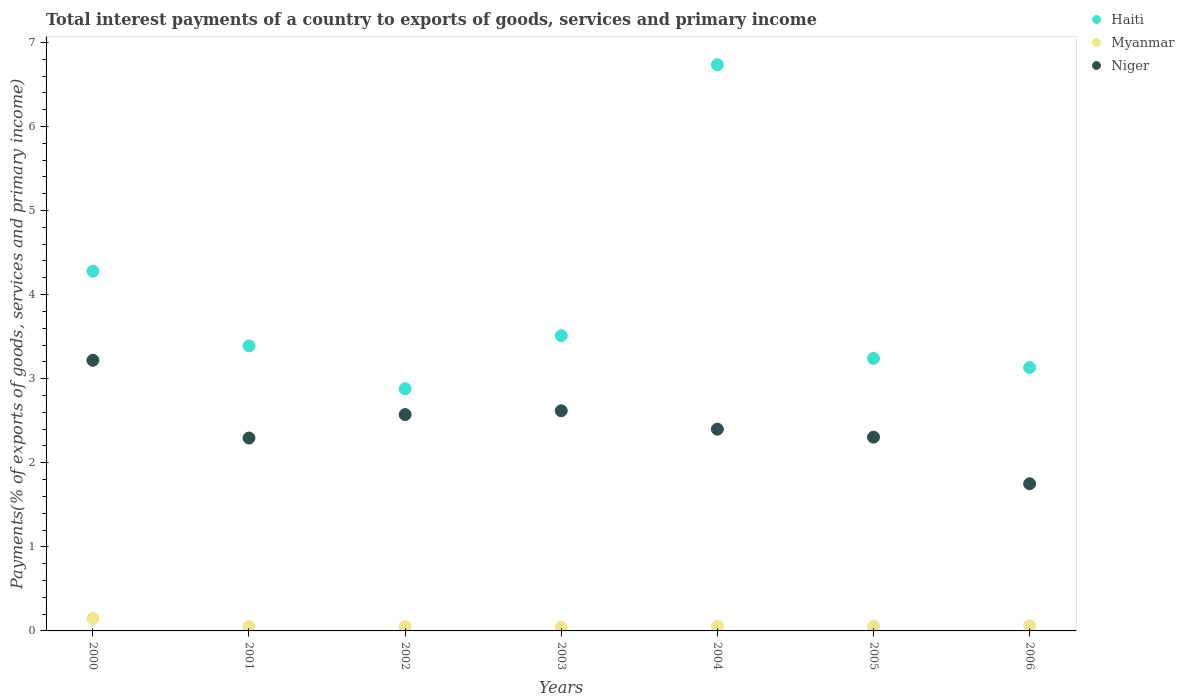How many different coloured dotlines are there?
Provide a short and direct response. 3. Is the number of dotlines equal to the number of legend labels?
Ensure brevity in your answer.  Yes. What is the total interest payments in Niger in 2003?
Your answer should be very brief. 2.62. Across all years, what is the maximum total interest payments in Myanmar?
Give a very brief answer. 0.15. Across all years, what is the minimum total interest payments in Haiti?
Make the answer very short. 2.88. In which year was the total interest payments in Niger maximum?
Offer a terse response. 2000. What is the total total interest payments in Haiti in the graph?
Make the answer very short. 27.17. What is the difference between the total interest payments in Haiti in 2002 and that in 2005?
Offer a terse response. -0.36. What is the difference between the total interest payments in Niger in 2005 and the total interest payments in Haiti in 2001?
Keep it short and to the point. -1.09. What is the average total interest payments in Haiti per year?
Provide a short and direct response. 3.88. In the year 2001, what is the difference between the total interest payments in Niger and total interest payments in Haiti?
Provide a short and direct response. -1.1. In how many years, is the total interest payments in Haiti greater than 6.2 %?
Provide a short and direct response. 1. What is the ratio of the total interest payments in Myanmar in 2004 to that in 2005?
Your response must be concise. 0.98. Is the total interest payments in Myanmar in 2001 less than that in 2002?
Keep it short and to the point. No. What is the difference between the highest and the second highest total interest payments in Myanmar?
Your answer should be compact. 0.09. What is the difference between the highest and the lowest total interest payments in Myanmar?
Provide a short and direct response. 0.11. Is the sum of the total interest payments in Myanmar in 2003 and 2005 greater than the maximum total interest payments in Haiti across all years?
Ensure brevity in your answer.  No. Is the total interest payments in Niger strictly greater than the total interest payments in Myanmar over the years?
Provide a short and direct response. Yes. How many dotlines are there?
Your answer should be very brief. 3. How many years are there in the graph?
Give a very brief answer. 7. What is the difference between two consecutive major ticks on the Y-axis?
Your answer should be compact. 1. Does the graph contain any zero values?
Offer a very short reply. No. Does the graph contain grids?
Your response must be concise. No. How many legend labels are there?
Your answer should be very brief. 3. How are the legend labels stacked?
Your answer should be very brief. Vertical. What is the title of the graph?
Your answer should be very brief. Total interest payments of a country to exports of goods, services and primary income. What is the label or title of the Y-axis?
Your answer should be very brief. Payments(% of exports of goods, services and primary income). What is the Payments(% of exports of goods, services and primary income) in Haiti in 2000?
Offer a terse response. 4.28. What is the Payments(% of exports of goods, services and primary income) of Myanmar in 2000?
Keep it short and to the point. 0.15. What is the Payments(% of exports of goods, services and primary income) of Niger in 2000?
Your answer should be very brief. 3.22. What is the Payments(% of exports of goods, services and primary income) of Haiti in 2001?
Your response must be concise. 3.39. What is the Payments(% of exports of goods, services and primary income) in Myanmar in 2001?
Provide a short and direct response. 0.05. What is the Payments(% of exports of goods, services and primary income) of Niger in 2001?
Keep it short and to the point. 2.29. What is the Payments(% of exports of goods, services and primary income) of Haiti in 2002?
Offer a terse response. 2.88. What is the Payments(% of exports of goods, services and primary income) in Myanmar in 2002?
Your response must be concise. 0.05. What is the Payments(% of exports of goods, services and primary income) of Niger in 2002?
Provide a succinct answer. 2.57. What is the Payments(% of exports of goods, services and primary income) in Haiti in 2003?
Your answer should be compact. 3.51. What is the Payments(% of exports of goods, services and primary income) in Myanmar in 2003?
Give a very brief answer. 0.04. What is the Payments(% of exports of goods, services and primary income) of Niger in 2003?
Provide a short and direct response. 2.62. What is the Payments(% of exports of goods, services and primary income) in Haiti in 2004?
Give a very brief answer. 6.73. What is the Payments(% of exports of goods, services and primary income) in Myanmar in 2004?
Your answer should be very brief. 0.05. What is the Payments(% of exports of goods, services and primary income) of Niger in 2004?
Offer a terse response. 2.4. What is the Payments(% of exports of goods, services and primary income) of Haiti in 2005?
Offer a very short reply. 3.24. What is the Payments(% of exports of goods, services and primary income) of Myanmar in 2005?
Ensure brevity in your answer.  0.05. What is the Payments(% of exports of goods, services and primary income) in Niger in 2005?
Keep it short and to the point. 2.3. What is the Payments(% of exports of goods, services and primary income) in Haiti in 2006?
Your response must be concise. 3.13. What is the Payments(% of exports of goods, services and primary income) in Myanmar in 2006?
Ensure brevity in your answer.  0.06. What is the Payments(% of exports of goods, services and primary income) of Niger in 2006?
Give a very brief answer. 1.75. Across all years, what is the maximum Payments(% of exports of goods, services and primary income) of Haiti?
Provide a succinct answer. 6.73. Across all years, what is the maximum Payments(% of exports of goods, services and primary income) of Myanmar?
Keep it short and to the point. 0.15. Across all years, what is the maximum Payments(% of exports of goods, services and primary income) in Niger?
Offer a terse response. 3.22. Across all years, what is the minimum Payments(% of exports of goods, services and primary income) in Haiti?
Offer a terse response. 2.88. Across all years, what is the minimum Payments(% of exports of goods, services and primary income) in Myanmar?
Ensure brevity in your answer.  0.04. Across all years, what is the minimum Payments(% of exports of goods, services and primary income) in Niger?
Provide a short and direct response. 1.75. What is the total Payments(% of exports of goods, services and primary income) in Haiti in the graph?
Your answer should be compact. 27.17. What is the total Payments(% of exports of goods, services and primary income) in Myanmar in the graph?
Keep it short and to the point. 0.46. What is the total Payments(% of exports of goods, services and primary income) in Niger in the graph?
Your response must be concise. 17.16. What is the difference between the Payments(% of exports of goods, services and primary income) in Haiti in 2000 and that in 2001?
Offer a very short reply. 0.89. What is the difference between the Payments(% of exports of goods, services and primary income) of Myanmar in 2000 and that in 2001?
Keep it short and to the point. 0.1. What is the difference between the Payments(% of exports of goods, services and primary income) in Niger in 2000 and that in 2001?
Keep it short and to the point. 0.92. What is the difference between the Payments(% of exports of goods, services and primary income) of Haiti in 2000 and that in 2002?
Provide a short and direct response. 1.4. What is the difference between the Payments(% of exports of goods, services and primary income) in Myanmar in 2000 and that in 2002?
Offer a very short reply. 0.1. What is the difference between the Payments(% of exports of goods, services and primary income) of Niger in 2000 and that in 2002?
Provide a succinct answer. 0.65. What is the difference between the Payments(% of exports of goods, services and primary income) in Haiti in 2000 and that in 2003?
Make the answer very short. 0.77. What is the difference between the Payments(% of exports of goods, services and primary income) in Myanmar in 2000 and that in 2003?
Keep it short and to the point. 0.11. What is the difference between the Payments(% of exports of goods, services and primary income) in Niger in 2000 and that in 2003?
Give a very brief answer. 0.6. What is the difference between the Payments(% of exports of goods, services and primary income) of Haiti in 2000 and that in 2004?
Provide a short and direct response. -2.46. What is the difference between the Payments(% of exports of goods, services and primary income) of Myanmar in 2000 and that in 2004?
Your response must be concise. 0.1. What is the difference between the Payments(% of exports of goods, services and primary income) of Niger in 2000 and that in 2004?
Ensure brevity in your answer.  0.82. What is the difference between the Payments(% of exports of goods, services and primary income) of Haiti in 2000 and that in 2005?
Offer a very short reply. 1.04. What is the difference between the Payments(% of exports of goods, services and primary income) in Myanmar in 2000 and that in 2005?
Give a very brief answer. 0.09. What is the difference between the Payments(% of exports of goods, services and primary income) of Niger in 2000 and that in 2005?
Keep it short and to the point. 0.91. What is the difference between the Payments(% of exports of goods, services and primary income) of Haiti in 2000 and that in 2006?
Your answer should be very brief. 1.15. What is the difference between the Payments(% of exports of goods, services and primary income) of Myanmar in 2000 and that in 2006?
Offer a terse response. 0.09. What is the difference between the Payments(% of exports of goods, services and primary income) of Niger in 2000 and that in 2006?
Your answer should be compact. 1.47. What is the difference between the Payments(% of exports of goods, services and primary income) in Haiti in 2001 and that in 2002?
Provide a short and direct response. 0.51. What is the difference between the Payments(% of exports of goods, services and primary income) of Myanmar in 2001 and that in 2002?
Offer a terse response. 0. What is the difference between the Payments(% of exports of goods, services and primary income) of Niger in 2001 and that in 2002?
Keep it short and to the point. -0.28. What is the difference between the Payments(% of exports of goods, services and primary income) in Haiti in 2001 and that in 2003?
Give a very brief answer. -0.12. What is the difference between the Payments(% of exports of goods, services and primary income) of Myanmar in 2001 and that in 2003?
Keep it short and to the point. 0.01. What is the difference between the Payments(% of exports of goods, services and primary income) in Niger in 2001 and that in 2003?
Offer a terse response. -0.32. What is the difference between the Payments(% of exports of goods, services and primary income) of Haiti in 2001 and that in 2004?
Your response must be concise. -3.34. What is the difference between the Payments(% of exports of goods, services and primary income) of Myanmar in 2001 and that in 2004?
Give a very brief answer. -0. What is the difference between the Payments(% of exports of goods, services and primary income) in Niger in 2001 and that in 2004?
Your response must be concise. -0.11. What is the difference between the Payments(% of exports of goods, services and primary income) in Haiti in 2001 and that in 2005?
Your answer should be very brief. 0.15. What is the difference between the Payments(% of exports of goods, services and primary income) in Myanmar in 2001 and that in 2005?
Give a very brief answer. -0. What is the difference between the Payments(% of exports of goods, services and primary income) of Niger in 2001 and that in 2005?
Provide a succinct answer. -0.01. What is the difference between the Payments(% of exports of goods, services and primary income) of Haiti in 2001 and that in 2006?
Ensure brevity in your answer.  0.26. What is the difference between the Payments(% of exports of goods, services and primary income) in Myanmar in 2001 and that in 2006?
Offer a terse response. -0.01. What is the difference between the Payments(% of exports of goods, services and primary income) in Niger in 2001 and that in 2006?
Your answer should be very brief. 0.54. What is the difference between the Payments(% of exports of goods, services and primary income) in Haiti in 2002 and that in 2003?
Give a very brief answer. -0.63. What is the difference between the Payments(% of exports of goods, services and primary income) in Myanmar in 2002 and that in 2003?
Provide a short and direct response. 0.01. What is the difference between the Payments(% of exports of goods, services and primary income) of Niger in 2002 and that in 2003?
Ensure brevity in your answer.  -0.05. What is the difference between the Payments(% of exports of goods, services and primary income) of Haiti in 2002 and that in 2004?
Ensure brevity in your answer.  -3.85. What is the difference between the Payments(% of exports of goods, services and primary income) in Myanmar in 2002 and that in 2004?
Give a very brief answer. -0. What is the difference between the Payments(% of exports of goods, services and primary income) in Niger in 2002 and that in 2004?
Ensure brevity in your answer.  0.17. What is the difference between the Payments(% of exports of goods, services and primary income) of Haiti in 2002 and that in 2005?
Offer a terse response. -0.36. What is the difference between the Payments(% of exports of goods, services and primary income) of Myanmar in 2002 and that in 2005?
Offer a terse response. -0. What is the difference between the Payments(% of exports of goods, services and primary income) in Niger in 2002 and that in 2005?
Your response must be concise. 0.27. What is the difference between the Payments(% of exports of goods, services and primary income) of Haiti in 2002 and that in 2006?
Your answer should be very brief. -0.25. What is the difference between the Payments(% of exports of goods, services and primary income) of Myanmar in 2002 and that in 2006?
Give a very brief answer. -0.01. What is the difference between the Payments(% of exports of goods, services and primary income) of Niger in 2002 and that in 2006?
Keep it short and to the point. 0.82. What is the difference between the Payments(% of exports of goods, services and primary income) of Haiti in 2003 and that in 2004?
Make the answer very short. -3.22. What is the difference between the Payments(% of exports of goods, services and primary income) in Myanmar in 2003 and that in 2004?
Keep it short and to the point. -0.01. What is the difference between the Payments(% of exports of goods, services and primary income) of Niger in 2003 and that in 2004?
Ensure brevity in your answer.  0.22. What is the difference between the Payments(% of exports of goods, services and primary income) of Haiti in 2003 and that in 2005?
Give a very brief answer. 0.27. What is the difference between the Payments(% of exports of goods, services and primary income) in Myanmar in 2003 and that in 2005?
Your response must be concise. -0.01. What is the difference between the Payments(% of exports of goods, services and primary income) of Niger in 2003 and that in 2005?
Ensure brevity in your answer.  0.31. What is the difference between the Payments(% of exports of goods, services and primary income) in Haiti in 2003 and that in 2006?
Keep it short and to the point. 0.38. What is the difference between the Payments(% of exports of goods, services and primary income) in Myanmar in 2003 and that in 2006?
Offer a terse response. -0.02. What is the difference between the Payments(% of exports of goods, services and primary income) in Niger in 2003 and that in 2006?
Your answer should be compact. 0.87. What is the difference between the Payments(% of exports of goods, services and primary income) in Haiti in 2004 and that in 2005?
Offer a terse response. 3.49. What is the difference between the Payments(% of exports of goods, services and primary income) in Myanmar in 2004 and that in 2005?
Provide a short and direct response. -0. What is the difference between the Payments(% of exports of goods, services and primary income) in Niger in 2004 and that in 2005?
Provide a succinct answer. 0.09. What is the difference between the Payments(% of exports of goods, services and primary income) of Haiti in 2004 and that in 2006?
Give a very brief answer. 3.6. What is the difference between the Payments(% of exports of goods, services and primary income) in Myanmar in 2004 and that in 2006?
Make the answer very short. -0.01. What is the difference between the Payments(% of exports of goods, services and primary income) of Niger in 2004 and that in 2006?
Provide a short and direct response. 0.65. What is the difference between the Payments(% of exports of goods, services and primary income) in Haiti in 2005 and that in 2006?
Give a very brief answer. 0.11. What is the difference between the Payments(% of exports of goods, services and primary income) of Myanmar in 2005 and that in 2006?
Give a very brief answer. -0.01. What is the difference between the Payments(% of exports of goods, services and primary income) of Niger in 2005 and that in 2006?
Ensure brevity in your answer.  0.55. What is the difference between the Payments(% of exports of goods, services and primary income) in Haiti in 2000 and the Payments(% of exports of goods, services and primary income) in Myanmar in 2001?
Ensure brevity in your answer.  4.23. What is the difference between the Payments(% of exports of goods, services and primary income) of Haiti in 2000 and the Payments(% of exports of goods, services and primary income) of Niger in 2001?
Your response must be concise. 1.98. What is the difference between the Payments(% of exports of goods, services and primary income) of Myanmar in 2000 and the Payments(% of exports of goods, services and primary income) of Niger in 2001?
Provide a short and direct response. -2.15. What is the difference between the Payments(% of exports of goods, services and primary income) in Haiti in 2000 and the Payments(% of exports of goods, services and primary income) in Myanmar in 2002?
Offer a very short reply. 4.23. What is the difference between the Payments(% of exports of goods, services and primary income) in Haiti in 2000 and the Payments(% of exports of goods, services and primary income) in Niger in 2002?
Provide a short and direct response. 1.71. What is the difference between the Payments(% of exports of goods, services and primary income) of Myanmar in 2000 and the Payments(% of exports of goods, services and primary income) of Niger in 2002?
Keep it short and to the point. -2.42. What is the difference between the Payments(% of exports of goods, services and primary income) of Haiti in 2000 and the Payments(% of exports of goods, services and primary income) of Myanmar in 2003?
Keep it short and to the point. 4.24. What is the difference between the Payments(% of exports of goods, services and primary income) of Haiti in 2000 and the Payments(% of exports of goods, services and primary income) of Niger in 2003?
Provide a succinct answer. 1.66. What is the difference between the Payments(% of exports of goods, services and primary income) of Myanmar in 2000 and the Payments(% of exports of goods, services and primary income) of Niger in 2003?
Offer a terse response. -2.47. What is the difference between the Payments(% of exports of goods, services and primary income) in Haiti in 2000 and the Payments(% of exports of goods, services and primary income) in Myanmar in 2004?
Ensure brevity in your answer.  4.23. What is the difference between the Payments(% of exports of goods, services and primary income) of Haiti in 2000 and the Payments(% of exports of goods, services and primary income) of Niger in 2004?
Offer a very short reply. 1.88. What is the difference between the Payments(% of exports of goods, services and primary income) of Myanmar in 2000 and the Payments(% of exports of goods, services and primary income) of Niger in 2004?
Ensure brevity in your answer.  -2.25. What is the difference between the Payments(% of exports of goods, services and primary income) in Haiti in 2000 and the Payments(% of exports of goods, services and primary income) in Myanmar in 2005?
Provide a succinct answer. 4.22. What is the difference between the Payments(% of exports of goods, services and primary income) in Haiti in 2000 and the Payments(% of exports of goods, services and primary income) in Niger in 2005?
Offer a terse response. 1.97. What is the difference between the Payments(% of exports of goods, services and primary income) of Myanmar in 2000 and the Payments(% of exports of goods, services and primary income) of Niger in 2005?
Offer a very short reply. -2.16. What is the difference between the Payments(% of exports of goods, services and primary income) in Haiti in 2000 and the Payments(% of exports of goods, services and primary income) in Myanmar in 2006?
Provide a succinct answer. 4.22. What is the difference between the Payments(% of exports of goods, services and primary income) in Haiti in 2000 and the Payments(% of exports of goods, services and primary income) in Niger in 2006?
Your response must be concise. 2.53. What is the difference between the Payments(% of exports of goods, services and primary income) of Myanmar in 2000 and the Payments(% of exports of goods, services and primary income) of Niger in 2006?
Ensure brevity in your answer.  -1.6. What is the difference between the Payments(% of exports of goods, services and primary income) in Haiti in 2001 and the Payments(% of exports of goods, services and primary income) in Myanmar in 2002?
Your answer should be very brief. 3.34. What is the difference between the Payments(% of exports of goods, services and primary income) in Haiti in 2001 and the Payments(% of exports of goods, services and primary income) in Niger in 2002?
Offer a very short reply. 0.82. What is the difference between the Payments(% of exports of goods, services and primary income) of Myanmar in 2001 and the Payments(% of exports of goods, services and primary income) of Niger in 2002?
Keep it short and to the point. -2.52. What is the difference between the Payments(% of exports of goods, services and primary income) of Haiti in 2001 and the Payments(% of exports of goods, services and primary income) of Myanmar in 2003?
Your answer should be very brief. 3.35. What is the difference between the Payments(% of exports of goods, services and primary income) of Haiti in 2001 and the Payments(% of exports of goods, services and primary income) of Niger in 2003?
Provide a succinct answer. 0.77. What is the difference between the Payments(% of exports of goods, services and primary income) of Myanmar in 2001 and the Payments(% of exports of goods, services and primary income) of Niger in 2003?
Offer a terse response. -2.57. What is the difference between the Payments(% of exports of goods, services and primary income) in Haiti in 2001 and the Payments(% of exports of goods, services and primary income) in Myanmar in 2004?
Your answer should be compact. 3.34. What is the difference between the Payments(% of exports of goods, services and primary income) of Myanmar in 2001 and the Payments(% of exports of goods, services and primary income) of Niger in 2004?
Offer a terse response. -2.35. What is the difference between the Payments(% of exports of goods, services and primary income) of Haiti in 2001 and the Payments(% of exports of goods, services and primary income) of Myanmar in 2005?
Your answer should be compact. 3.34. What is the difference between the Payments(% of exports of goods, services and primary income) of Haiti in 2001 and the Payments(% of exports of goods, services and primary income) of Niger in 2005?
Your response must be concise. 1.09. What is the difference between the Payments(% of exports of goods, services and primary income) in Myanmar in 2001 and the Payments(% of exports of goods, services and primary income) in Niger in 2005?
Give a very brief answer. -2.25. What is the difference between the Payments(% of exports of goods, services and primary income) in Haiti in 2001 and the Payments(% of exports of goods, services and primary income) in Myanmar in 2006?
Keep it short and to the point. 3.33. What is the difference between the Payments(% of exports of goods, services and primary income) in Haiti in 2001 and the Payments(% of exports of goods, services and primary income) in Niger in 2006?
Your answer should be compact. 1.64. What is the difference between the Payments(% of exports of goods, services and primary income) in Myanmar in 2001 and the Payments(% of exports of goods, services and primary income) in Niger in 2006?
Provide a short and direct response. -1.7. What is the difference between the Payments(% of exports of goods, services and primary income) in Haiti in 2002 and the Payments(% of exports of goods, services and primary income) in Myanmar in 2003?
Offer a very short reply. 2.84. What is the difference between the Payments(% of exports of goods, services and primary income) of Haiti in 2002 and the Payments(% of exports of goods, services and primary income) of Niger in 2003?
Provide a short and direct response. 0.26. What is the difference between the Payments(% of exports of goods, services and primary income) of Myanmar in 2002 and the Payments(% of exports of goods, services and primary income) of Niger in 2003?
Your answer should be very brief. -2.57. What is the difference between the Payments(% of exports of goods, services and primary income) of Haiti in 2002 and the Payments(% of exports of goods, services and primary income) of Myanmar in 2004?
Provide a short and direct response. 2.83. What is the difference between the Payments(% of exports of goods, services and primary income) in Haiti in 2002 and the Payments(% of exports of goods, services and primary income) in Niger in 2004?
Keep it short and to the point. 0.48. What is the difference between the Payments(% of exports of goods, services and primary income) in Myanmar in 2002 and the Payments(% of exports of goods, services and primary income) in Niger in 2004?
Provide a short and direct response. -2.35. What is the difference between the Payments(% of exports of goods, services and primary income) in Haiti in 2002 and the Payments(% of exports of goods, services and primary income) in Myanmar in 2005?
Offer a very short reply. 2.83. What is the difference between the Payments(% of exports of goods, services and primary income) in Haiti in 2002 and the Payments(% of exports of goods, services and primary income) in Niger in 2005?
Provide a short and direct response. 0.58. What is the difference between the Payments(% of exports of goods, services and primary income) in Myanmar in 2002 and the Payments(% of exports of goods, services and primary income) in Niger in 2005?
Your answer should be very brief. -2.25. What is the difference between the Payments(% of exports of goods, services and primary income) in Haiti in 2002 and the Payments(% of exports of goods, services and primary income) in Myanmar in 2006?
Give a very brief answer. 2.82. What is the difference between the Payments(% of exports of goods, services and primary income) in Haiti in 2002 and the Payments(% of exports of goods, services and primary income) in Niger in 2006?
Make the answer very short. 1.13. What is the difference between the Payments(% of exports of goods, services and primary income) in Myanmar in 2002 and the Payments(% of exports of goods, services and primary income) in Niger in 2006?
Make the answer very short. -1.7. What is the difference between the Payments(% of exports of goods, services and primary income) in Haiti in 2003 and the Payments(% of exports of goods, services and primary income) in Myanmar in 2004?
Provide a succinct answer. 3.46. What is the difference between the Payments(% of exports of goods, services and primary income) in Haiti in 2003 and the Payments(% of exports of goods, services and primary income) in Niger in 2004?
Offer a terse response. 1.11. What is the difference between the Payments(% of exports of goods, services and primary income) in Myanmar in 2003 and the Payments(% of exports of goods, services and primary income) in Niger in 2004?
Your answer should be very brief. -2.36. What is the difference between the Payments(% of exports of goods, services and primary income) in Haiti in 2003 and the Payments(% of exports of goods, services and primary income) in Myanmar in 2005?
Your response must be concise. 3.46. What is the difference between the Payments(% of exports of goods, services and primary income) in Haiti in 2003 and the Payments(% of exports of goods, services and primary income) in Niger in 2005?
Offer a terse response. 1.21. What is the difference between the Payments(% of exports of goods, services and primary income) in Myanmar in 2003 and the Payments(% of exports of goods, services and primary income) in Niger in 2005?
Provide a short and direct response. -2.26. What is the difference between the Payments(% of exports of goods, services and primary income) in Haiti in 2003 and the Payments(% of exports of goods, services and primary income) in Myanmar in 2006?
Your answer should be compact. 3.45. What is the difference between the Payments(% of exports of goods, services and primary income) of Haiti in 2003 and the Payments(% of exports of goods, services and primary income) of Niger in 2006?
Offer a very short reply. 1.76. What is the difference between the Payments(% of exports of goods, services and primary income) of Myanmar in 2003 and the Payments(% of exports of goods, services and primary income) of Niger in 2006?
Provide a succinct answer. -1.71. What is the difference between the Payments(% of exports of goods, services and primary income) of Haiti in 2004 and the Payments(% of exports of goods, services and primary income) of Myanmar in 2005?
Ensure brevity in your answer.  6.68. What is the difference between the Payments(% of exports of goods, services and primary income) in Haiti in 2004 and the Payments(% of exports of goods, services and primary income) in Niger in 2005?
Provide a succinct answer. 4.43. What is the difference between the Payments(% of exports of goods, services and primary income) of Myanmar in 2004 and the Payments(% of exports of goods, services and primary income) of Niger in 2005?
Make the answer very short. -2.25. What is the difference between the Payments(% of exports of goods, services and primary income) of Haiti in 2004 and the Payments(% of exports of goods, services and primary income) of Myanmar in 2006?
Your answer should be compact. 6.67. What is the difference between the Payments(% of exports of goods, services and primary income) in Haiti in 2004 and the Payments(% of exports of goods, services and primary income) in Niger in 2006?
Keep it short and to the point. 4.98. What is the difference between the Payments(% of exports of goods, services and primary income) in Myanmar in 2004 and the Payments(% of exports of goods, services and primary income) in Niger in 2006?
Your answer should be very brief. -1.7. What is the difference between the Payments(% of exports of goods, services and primary income) of Haiti in 2005 and the Payments(% of exports of goods, services and primary income) of Myanmar in 2006?
Keep it short and to the point. 3.18. What is the difference between the Payments(% of exports of goods, services and primary income) of Haiti in 2005 and the Payments(% of exports of goods, services and primary income) of Niger in 2006?
Provide a succinct answer. 1.49. What is the difference between the Payments(% of exports of goods, services and primary income) in Myanmar in 2005 and the Payments(% of exports of goods, services and primary income) in Niger in 2006?
Make the answer very short. -1.7. What is the average Payments(% of exports of goods, services and primary income) of Haiti per year?
Offer a terse response. 3.88. What is the average Payments(% of exports of goods, services and primary income) of Myanmar per year?
Provide a short and direct response. 0.07. What is the average Payments(% of exports of goods, services and primary income) of Niger per year?
Offer a very short reply. 2.45. In the year 2000, what is the difference between the Payments(% of exports of goods, services and primary income) in Haiti and Payments(% of exports of goods, services and primary income) in Myanmar?
Ensure brevity in your answer.  4.13. In the year 2000, what is the difference between the Payments(% of exports of goods, services and primary income) in Haiti and Payments(% of exports of goods, services and primary income) in Niger?
Provide a short and direct response. 1.06. In the year 2000, what is the difference between the Payments(% of exports of goods, services and primary income) in Myanmar and Payments(% of exports of goods, services and primary income) in Niger?
Your answer should be compact. -3.07. In the year 2001, what is the difference between the Payments(% of exports of goods, services and primary income) in Haiti and Payments(% of exports of goods, services and primary income) in Myanmar?
Provide a succinct answer. 3.34. In the year 2001, what is the difference between the Payments(% of exports of goods, services and primary income) in Haiti and Payments(% of exports of goods, services and primary income) in Niger?
Keep it short and to the point. 1.1. In the year 2001, what is the difference between the Payments(% of exports of goods, services and primary income) of Myanmar and Payments(% of exports of goods, services and primary income) of Niger?
Give a very brief answer. -2.24. In the year 2002, what is the difference between the Payments(% of exports of goods, services and primary income) in Haiti and Payments(% of exports of goods, services and primary income) in Myanmar?
Offer a very short reply. 2.83. In the year 2002, what is the difference between the Payments(% of exports of goods, services and primary income) of Haiti and Payments(% of exports of goods, services and primary income) of Niger?
Keep it short and to the point. 0.31. In the year 2002, what is the difference between the Payments(% of exports of goods, services and primary income) of Myanmar and Payments(% of exports of goods, services and primary income) of Niger?
Offer a very short reply. -2.52. In the year 2003, what is the difference between the Payments(% of exports of goods, services and primary income) of Haiti and Payments(% of exports of goods, services and primary income) of Myanmar?
Your answer should be very brief. 3.47. In the year 2003, what is the difference between the Payments(% of exports of goods, services and primary income) of Haiti and Payments(% of exports of goods, services and primary income) of Niger?
Your answer should be very brief. 0.89. In the year 2003, what is the difference between the Payments(% of exports of goods, services and primary income) of Myanmar and Payments(% of exports of goods, services and primary income) of Niger?
Your answer should be very brief. -2.58. In the year 2004, what is the difference between the Payments(% of exports of goods, services and primary income) of Haiti and Payments(% of exports of goods, services and primary income) of Myanmar?
Your response must be concise. 6.68. In the year 2004, what is the difference between the Payments(% of exports of goods, services and primary income) of Haiti and Payments(% of exports of goods, services and primary income) of Niger?
Provide a succinct answer. 4.34. In the year 2004, what is the difference between the Payments(% of exports of goods, services and primary income) of Myanmar and Payments(% of exports of goods, services and primary income) of Niger?
Make the answer very short. -2.35. In the year 2005, what is the difference between the Payments(% of exports of goods, services and primary income) of Haiti and Payments(% of exports of goods, services and primary income) of Myanmar?
Your answer should be very brief. 3.19. In the year 2005, what is the difference between the Payments(% of exports of goods, services and primary income) of Haiti and Payments(% of exports of goods, services and primary income) of Niger?
Provide a succinct answer. 0.94. In the year 2005, what is the difference between the Payments(% of exports of goods, services and primary income) of Myanmar and Payments(% of exports of goods, services and primary income) of Niger?
Your answer should be compact. -2.25. In the year 2006, what is the difference between the Payments(% of exports of goods, services and primary income) of Haiti and Payments(% of exports of goods, services and primary income) of Myanmar?
Make the answer very short. 3.07. In the year 2006, what is the difference between the Payments(% of exports of goods, services and primary income) in Haiti and Payments(% of exports of goods, services and primary income) in Niger?
Offer a terse response. 1.38. In the year 2006, what is the difference between the Payments(% of exports of goods, services and primary income) of Myanmar and Payments(% of exports of goods, services and primary income) of Niger?
Ensure brevity in your answer.  -1.69. What is the ratio of the Payments(% of exports of goods, services and primary income) in Haiti in 2000 to that in 2001?
Your answer should be very brief. 1.26. What is the ratio of the Payments(% of exports of goods, services and primary income) of Myanmar in 2000 to that in 2001?
Keep it short and to the point. 2.94. What is the ratio of the Payments(% of exports of goods, services and primary income) of Niger in 2000 to that in 2001?
Provide a short and direct response. 1.4. What is the ratio of the Payments(% of exports of goods, services and primary income) of Haiti in 2000 to that in 2002?
Offer a very short reply. 1.49. What is the ratio of the Payments(% of exports of goods, services and primary income) of Myanmar in 2000 to that in 2002?
Your response must be concise. 2.96. What is the ratio of the Payments(% of exports of goods, services and primary income) of Niger in 2000 to that in 2002?
Make the answer very short. 1.25. What is the ratio of the Payments(% of exports of goods, services and primary income) in Haiti in 2000 to that in 2003?
Make the answer very short. 1.22. What is the ratio of the Payments(% of exports of goods, services and primary income) of Myanmar in 2000 to that in 2003?
Your answer should be compact. 3.54. What is the ratio of the Payments(% of exports of goods, services and primary income) in Niger in 2000 to that in 2003?
Give a very brief answer. 1.23. What is the ratio of the Payments(% of exports of goods, services and primary income) of Haiti in 2000 to that in 2004?
Give a very brief answer. 0.64. What is the ratio of the Payments(% of exports of goods, services and primary income) in Myanmar in 2000 to that in 2004?
Give a very brief answer. 2.81. What is the ratio of the Payments(% of exports of goods, services and primary income) in Niger in 2000 to that in 2004?
Make the answer very short. 1.34. What is the ratio of the Payments(% of exports of goods, services and primary income) of Haiti in 2000 to that in 2005?
Provide a short and direct response. 1.32. What is the ratio of the Payments(% of exports of goods, services and primary income) in Myanmar in 2000 to that in 2005?
Your answer should be compact. 2.75. What is the ratio of the Payments(% of exports of goods, services and primary income) of Niger in 2000 to that in 2005?
Keep it short and to the point. 1.4. What is the ratio of the Payments(% of exports of goods, services and primary income) of Haiti in 2000 to that in 2006?
Provide a succinct answer. 1.37. What is the ratio of the Payments(% of exports of goods, services and primary income) of Myanmar in 2000 to that in 2006?
Make the answer very short. 2.39. What is the ratio of the Payments(% of exports of goods, services and primary income) of Niger in 2000 to that in 2006?
Your response must be concise. 1.84. What is the ratio of the Payments(% of exports of goods, services and primary income) in Haiti in 2001 to that in 2002?
Your answer should be compact. 1.18. What is the ratio of the Payments(% of exports of goods, services and primary income) of Myanmar in 2001 to that in 2002?
Your response must be concise. 1.01. What is the ratio of the Payments(% of exports of goods, services and primary income) of Niger in 2001 to that in 2002?
Offer a terse response. 0.89. What is the ratio of the Payments(% of exports of goods, services and primary income) in Haiti in 2001 to that in 2003?
Provide a short and direct response. 0.97. What is the ratio of the Payments(% of exports of goods, services and primary income) in Myanmar in 2001 to that in 2003?
Keep it short and to the point. 1.2. What is the ratio of the Payments(% of exports of goods, services and primary income) of Niger in 2001 to that in 2003?
Your response must be concise. 0.88. What is the ratio of the Payments(% of exports of goods, services and primary income) in Haiti in 2001 to that in 2004?
Provide a succinct answer. 0.5. What is the ratio of the Payments(% of exports of goods, services and primary income) of Myanmar in 2001 to that in 2004?
Ensure brevity in your answer.  0.96. What is the ratio of the Payments(% of exports of goods, services and primary income) of Niger in 2001 to that in 2004?
Give a very brief answer. 0.96. What is the ratio of the Payments(% of exports of goods, services and primary income) of Haiti in 2001 to that in 2005?
Ensure brevity in your answer.  1.05. What is the ratio of the Payments(% of exports of goods, services and primary income) of Myanmar in 2001 to that in 2005?
Your answer should be compact. 0.93. What is the ratio of the Payments(% of exports of goods, services and primary income) of Haiti in 2001 to that in 2006?
Your response must be concise. 1.08. What is the ratio of the Payments(% of exports of goods, services and primary income) in Myanmar in 2001 to that in 2006?
Your answer should be very brief. 0.81. What is the ratio of the Payments(% of exports of goods, services and primary income) in Niger in 2001 to that in 2006?
Ensure brevity in your answer.  1.31. What is the ratio of the Payments(% of exports of goods, services and primary income) in Haiti in 2002 to that in 2003?
Make the answer very short. 0.82. What is the ratio of the Payments(% of exports of goods, services and primary income) in Myanmar in 2002 to that in 2003?
Ensure brevity in your answer.  1.2. What is the ratio of the Payments(% of exports of goods, services and primary income) in Niger in 2002 to that in 2003?
Offer a very short reply. 0.98. What is the ratio of the Payments(% of exports of goods, services and primary income) in Haiti in 2002 to that in 2004?
Offer a terse response. 0.43. What is the ratio of the Payments(% of exports of goods, services and primary income) of Myanmar in 2002 to that in 2004?
Your response must be concise. 0.95. What is the ratio of the Payments(% of exports of goods, services and primary income) of Niger in 2002 to that in 2004?
Give a very brief answer. 1.07. What is the ratio of the Payments(% of exports of goods, services and primary income) of Haiti in 2002 to that in 2005?
Provide a succinct answer. 0.89. What is the ratio of the Payments(% of exports of goods, services and primary income) in Myanmar in 2002 to that in 2005?
Provide a succinct answer. 0.93. What is the ratio of the Payments(% of exports of goods, services and primary income) in Niger in 2002 to that in 2005?
Your answer should be compact. 1.12. What is the ratio of the Payments(% of exports of goods, services and primary income) in Haiti in 2002 to that in 2006?
Your answer should be compact. 0.92. What is the ratio of the Payments(% of exports of goods, services and primary income) of Myanmar in 2002 to that in 2006?
Provide a short and direct response. 0.81. What is the ratio of the Payments(% of exports of goods, services and primary income) in Niger in 2002 to that in 2006?
Your response must be concise. 1.47. What is the ratio of the Payments(% of exports of goods, services and primary income) of Haiti in 2003 to that in 2004?
Provide a succinct answer. 0.52. What is the ratio of the Payments(% of exports of goods, services and primary income) of Myanmar in 2003 to that in 2004?
Your response must be concise. 0.8. What is the ratio of the Payments(% of exports of goods, services and primary income) in Niger in 2003 to that in 2004?
Your answer should be very brief. 1.09. What is the ratio of the Payments(% of exports of goods, services and primary income) of Haiti in 2003 to that in 2005?
Provide a succinct answer. 1.08. What is the ratio of the Payments(% of exports of goods, services and primary income) in Myanmar in 2003 to that in 2005?
Give a very brief answer. 0.78. What is the ratio of the Payments(% of exports of goods, services and primary income) of Niger in 2003 to that in 2005?
Provide a short and direct response. 1.14. What is the ratio of the Payments(% of exports of goods, services and primary income) in Haiti in 2003 to that in 2006?
Offer a very short reply. 1.12. What is the ratio of the Payments(% of exports of goods, services and primary income) of Myanmar in 2003 to that in 2006?
Provide a short and direct response. 0.68. What is the ratio of the Payments(% of exports of goods, services and primary income) of Niger in 2003 to that in 2006?
Your answer should be compact. 1.5. What is the ratio of the Payments(% of exports of goods, services and primary income) in Haiti in 2004 to that in 2005?
Provide a short and direct response. 2.08. What is the ratio of the Payments(% of exports of goods, services and primary income) of Myanmar in 2004 to that in 2005?
Keep it short and to the point. 0.98. What is the ratio of the Payments(% of exports of goods, services and primary income) of Niger in 2004 to that in 2005?
Provide a short and direct response. 1.04. What is the ratio of the Payments(% of exports of goods, services and primary income) of Haiti in 2004 to that in 2006?
Provide a succinct answer. 2.15. What is the ratio of the Payments(% of exports of goods, services and primary income) in Myanmar in 2004 to that in 2006?
Make the answer very short. 0.85. What is the ratio of the Payments(% of exports of goods, services and primary income) of Niger in 2004 to that in 2006?
Your response must be concise. 1.37. What is the ratio of the Payments(% of exports of goods, services and primary income) of Haiti in 2005 to that in 2006?
Keep it short and to the point. 1.03. What is the ratio of the Payments(% of exports of goods, services and primary income) of Myanmar in 2005 to that in 2006?
Offer a terse response. 0.87. What is the ratio of the Payments(% of exports of goods, services and primary income) in Niger in 2005 to that in 2006?
Keep it short and to the point. 1.32. What is the difference between the highest and the second highest Payments(% of exports of goods, services and primary income) of Haiti?
Give a very brief answer. 2.46. What is the difference between the highest and the second highest Payments(% of exports of goods, services and primary income) in Myanmar?
Provide a succinct answer. 0.09. What is the difference between the highest and the second highest Payments(% of exports of goods, services and primary income) of Niger?
Your answer should be compact. 0.6. What is the difference between the highest and the lowest Payments(% of exports of goods, services and primary income) in Haiti?
Provide a succinct answer. 3.85. What is the difference between the highest and the lowest Payments(% of exports of goods, services and primary income) in Myanmar?
Provide a succinct answer. 0.11. What is the difference between the highest and the lowest Payments(% of exports of goods, services and primary income) in Niger?
Ensure brevity in your answer.  1.47. 